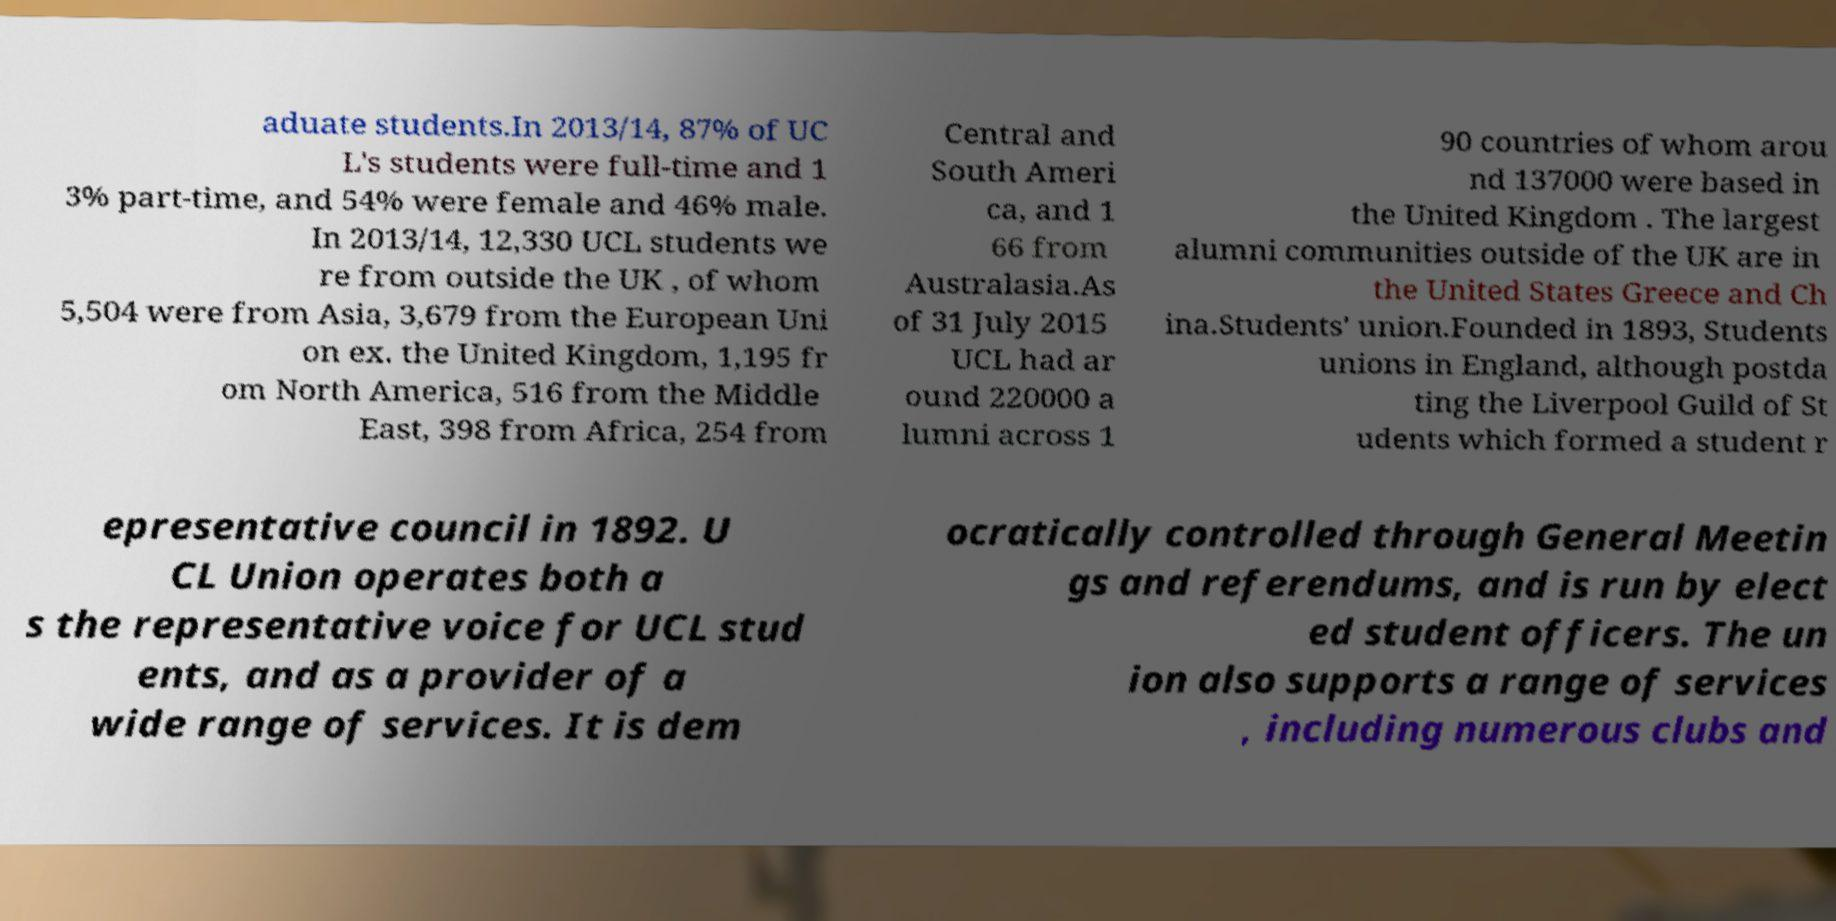I need the written content from this picture converted into text. Can you do that? aduate students.In 2013/14, 87% of UC L's students were full-time and 1 3% part-time, and 54% were female and 46% male. In 2013/14, 12,330 UCL students we re from outside the UK , of whom 5,504 were from Asia, 3,679 from the European Uni on ex. the United Kingdom, 1,195 fr om North America, 516 from the Middle East, 398 from Africa, 254 from Central and South Ameri ca, and 1 66 from Australasia.As of 31 July 2015 UCL had ar ound 220000 a lumni across 1 90 countries of whom arou nd 137000 were based in the United Kingdom . The largest alumni communities outside of the UK are in the United States Greece and Ch ina.Students' union.Founded in 1893, Students unions in England, although postda ting the Liverpool Guild of St udents which formed a student r epresentative council in 1892. U CL Union operates both a s the representative voice for UCL stud ents, and as a provider of a wide range of services. It is dem ocratically controlled through General Meetin gs and referendums, and is run by elect ed student officers. The un ion also supports a range of services , including numerous clubs and 